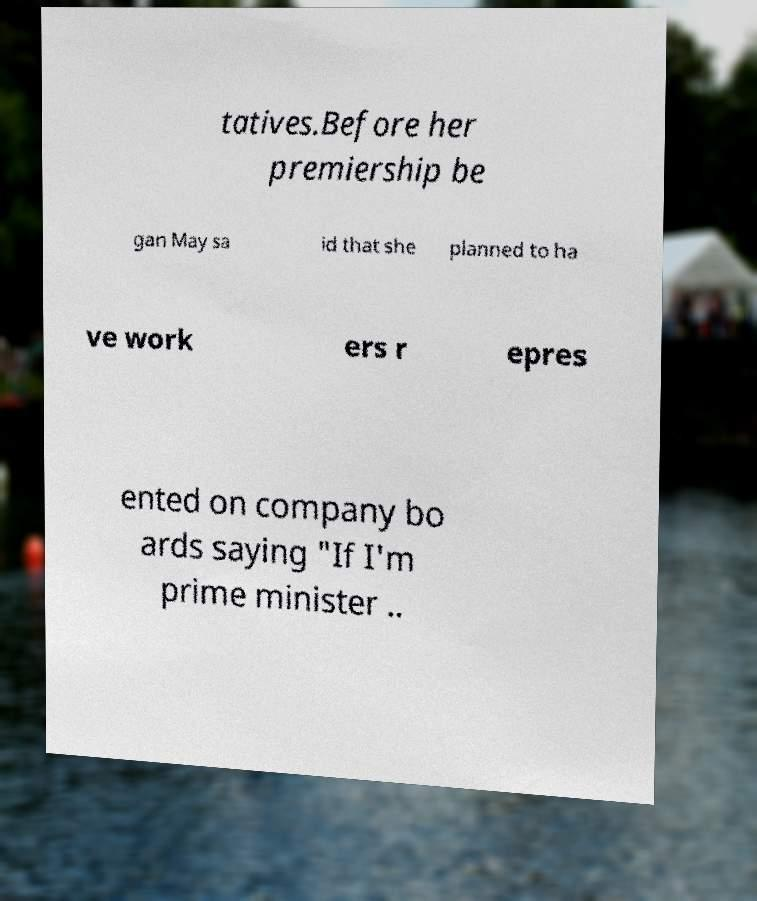I need the written content from this picture converted into text. Can you do that? tatives.Before her premiership be gan May sa id that she planned to ha ve work ers r epres ented on company bo ards saying "If I'm prime minister .. 